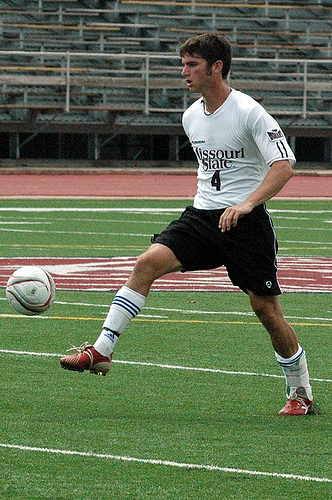<image>
Can you confirm if the man is to the left of the ball? Yes. From this viewpoint, the man is positioned to the left side relative to the ball. 